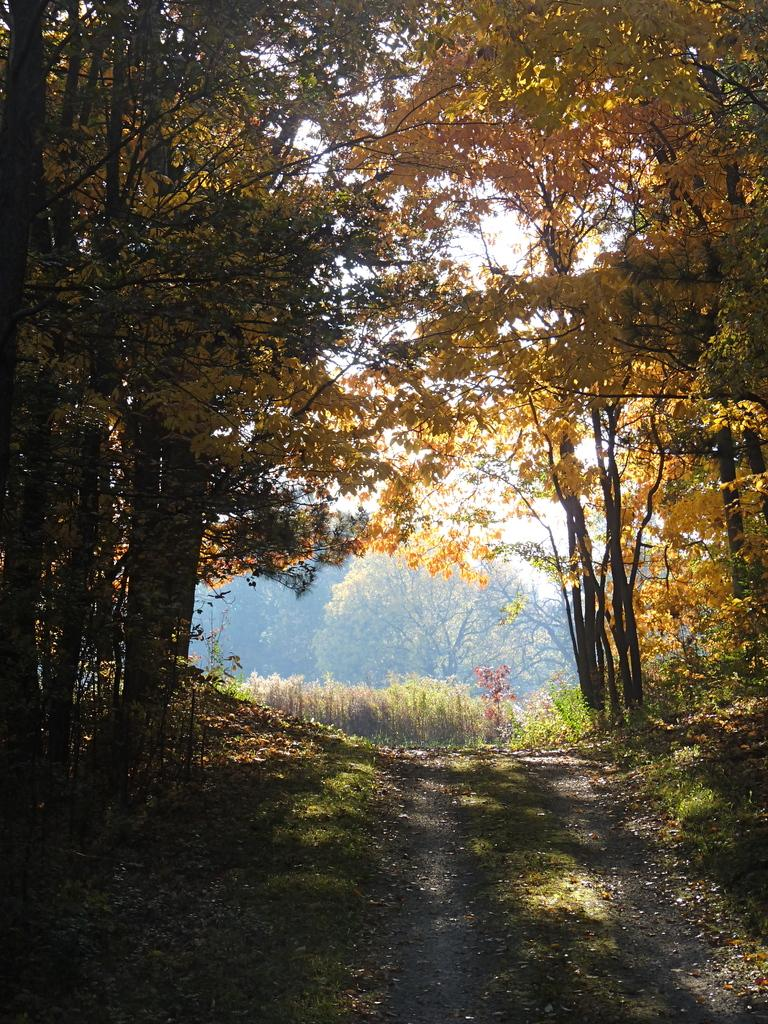What type of surface can be seen in the image? There is a path in the image. What type of vegetation is present in the image? Grass is present in the image. What additional objects can be seen on the ground in the image? Dry leaves are visible in the image. What type of natural structures are present in the image? There are trees in the image. What is visible in the background of the image? The sky is visible in the background of the image. Where is the oven located in the image? There is no oven present in the image. What type of vegetable can be seen growing near the trees in the image? There are no vegetables visible in the image; only grass, dry leaves, and trees are present. 